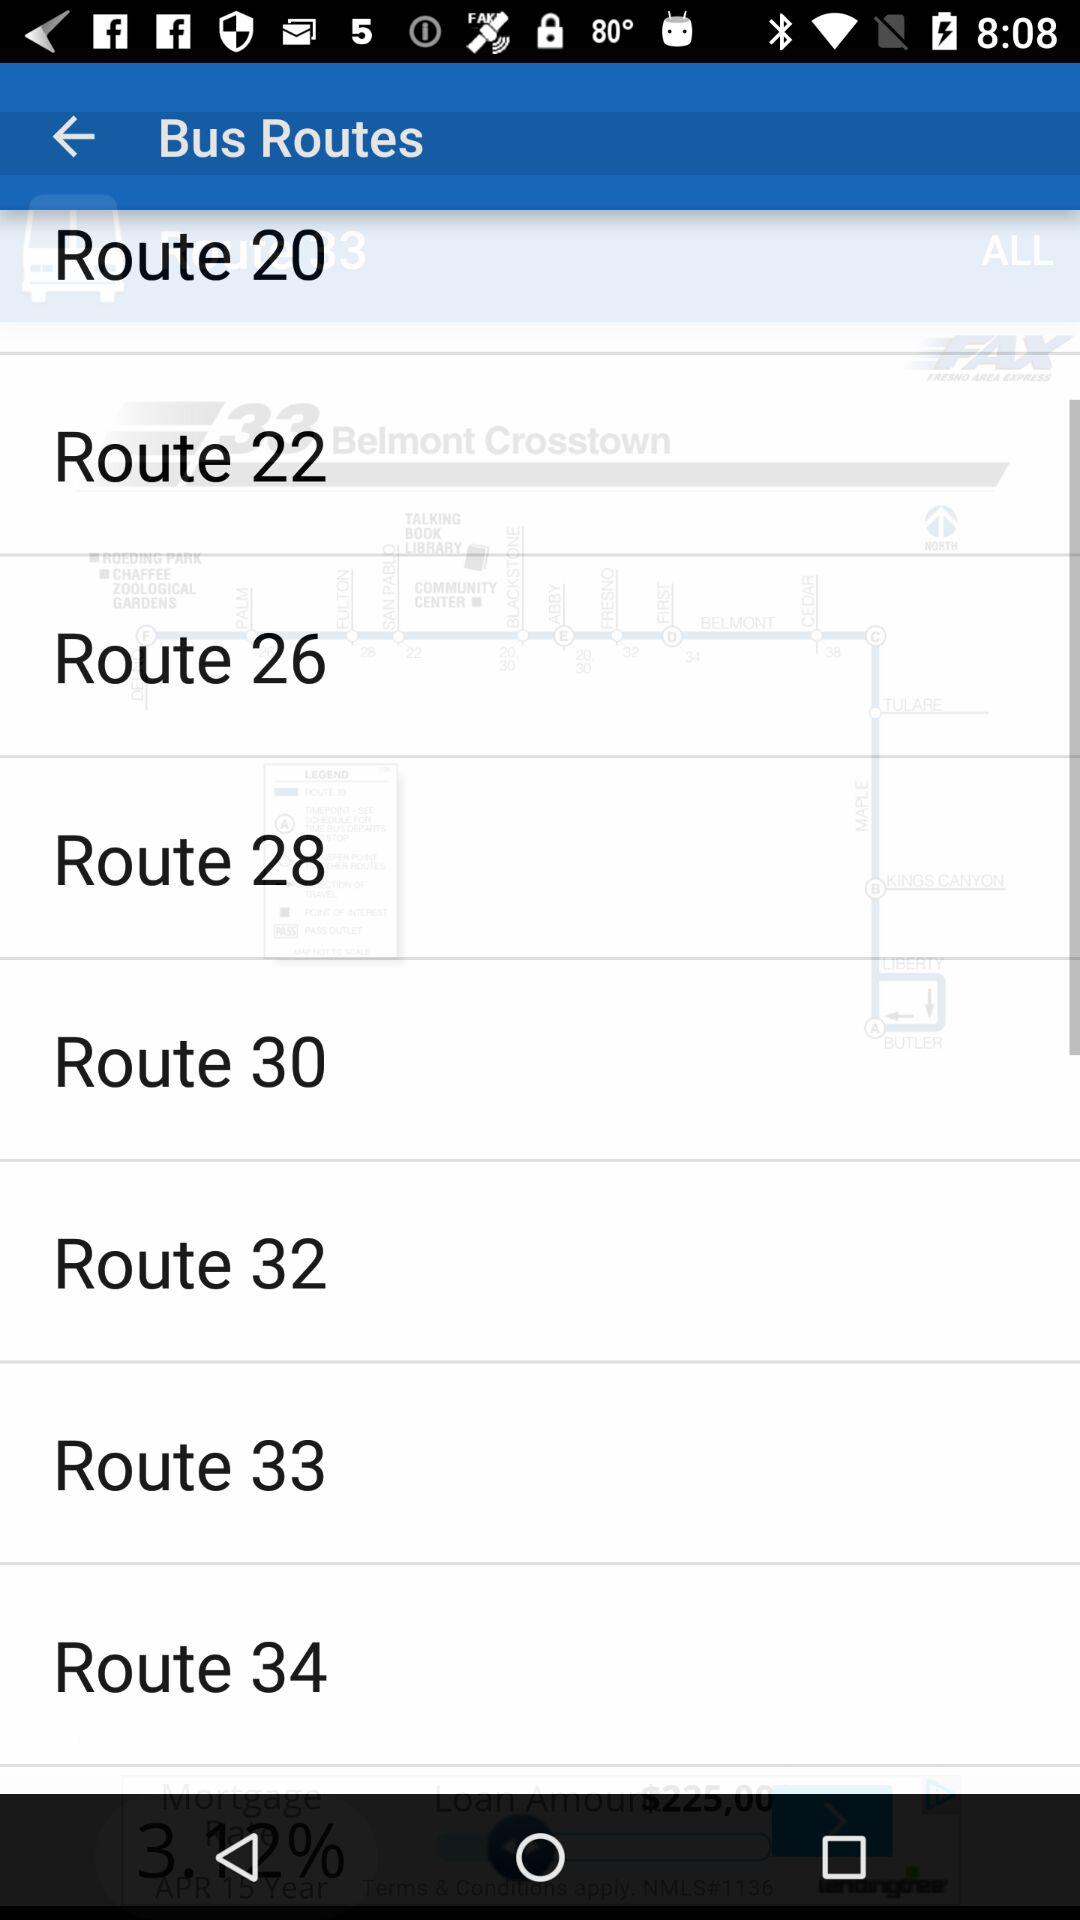What different bus routes are there? The different bus routes are Route 20, Route 22, Route 26, Route 28, Route 30, Route 32, Route 33 and Route 34. 